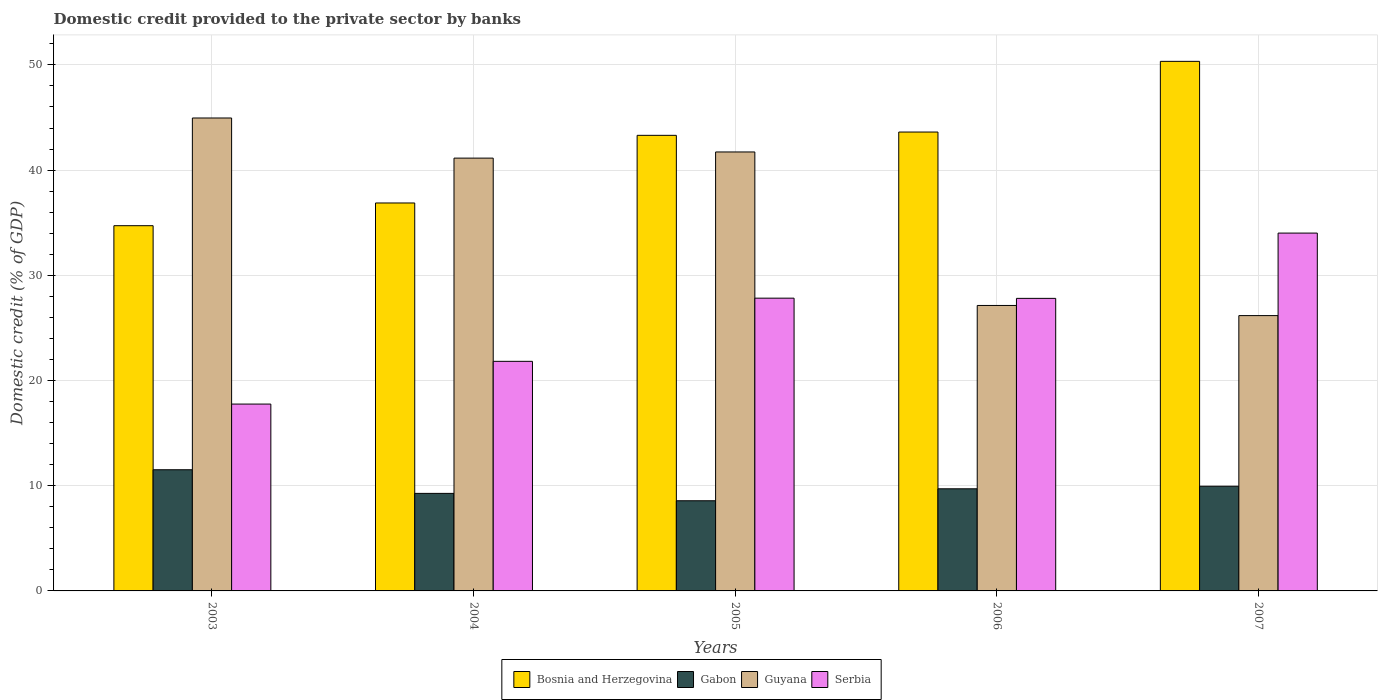How many bars are there on the 5th tick from the left?
Provide a succinct answer. 4. How many bars are there on the 2nd tick from the right?
Make the answer very short. 4. In how many cases, is the number of bars for a given year not equal to the number of legend labels?
Your response must be concise. 0. What is the domestic credit provided to the private sector by banks in Serbia in 2003?
Your response must be concise. 17.76. Across all years, what is the maximum domestic credit provided to the private sector by banks in Guyana?
Give a very brief answer. 44.96. Across all years, what is the minimum domestic credit provided to the private sector by banks in Guyana?
Your answer should be compact. 26.17. What is the total domestic credit provided to the private sector by banks in Serbia in the graph?
Ensure brevity in your answer.  129.24. What is the difference between the domestic credit provided to the private sector by banks in Guyana in 2004 and that in 2006?
Your response must be concise. 14. What is the difference between the domestic credit provided to the private sector by banks in Gabon in 2007 and the domestic credit provided to the private sector by banks in Bosnia and Herzegovina in 2003?
Your answer should be compact. -24.76. What is the average domestic credit provided to the private sector by banks in Gabon per year?
Offer a terse response. 9.8. In the year 2006, what is the difference between the domestic credit provided to the private sector by banks in Gabon and domestic credit provided to the private sector by banks in Guyana?
Your answer should be very brief. -17.43. In how many years, is the domestic credit provided to the private sector by banks in Bosnia and Herzegovina greater than 26 %?
Offer a terse response. 5. What is the ratio of the domestic credit provided to the private sector by banks in Guyana in 2004 to that in 2005?
Keep it short and to the point. 0.99. Is the domestic credit provided to the private sector by banks in Serbia in 2003 less than that in 2005?
Offer a terse response. Yes. Is the difference between the domestic credit provided to the private sector by banks in Gabon in 2003 and 2004 greater than the difference between the domestic credit provided to the private sector by banks in Guyana in 2003 and 2004?
Make the answer very short. No. What is the difference between the highest and the second highest domestic credit provided to the private sector by banks in Gabon?
Make the answer very short. 1.57. What is the difference between the highest and the lowest domestic credit provided to the private sector by banks in Guyana?
Your response must be concise. 18.78. In how many years, is the domestic credit provided to the private sector by banks in Serbia greater than the average domestic credit provided to the private sector by banks in Serbia taken over all years?
Your answer should be compact. 3. Is it the case that in every year, the sum of the domestic credit provided to the private sector by banks in Guyana and domestic credit provided to the private sector by banks in Gabon is greater than the sum of domestic credit provided to the private sector by banks in Serbia and domestic credit provided to the private sector by banks in Bosnia and Herzegovina?
Offer a terse response. No. What does the 4th bar from the left in 2006 represents?
Your answer should be compact. Serbia. What does the 1st bar from the right in 2004 represents?
Your answer should be very brief. Serbia. How many bars are there?
Offer a very short reply. 20. Are all the bars in the graph horizontal?
Give a very brief answer. No. How many years are there in the graph?
Your response must be concise. 5. Are the values on the major ticks of Y-axis written in scientific E-notation?
Your response must be concise. No. Does the graph contain any zero values?
Your answer should be very brief. No. Where does the legend appear in the graph?
Your response must be concise. Bottom center. How many legend labels are there?
Ensure brevity in your answer.  4. What is the title of the graph?
Make the answer very short. Domestic credit provided to the private sector by banks. What is the label or title of the Y-axis?
Your answer should be compact. Domestic credit (% of GDP). What is the Domestic credit (% of GDP) in Bosnia and Herzegovina in 2003?
Provide a short and direct response. 34.72. What is the Domestic credit (% of GDP) in Gabon in 2003?
Make the answer very short. 11.52. What is the Domestic credit (% of GDP) of Guyana in 2003?
Your answer should be compact. 44.96. What is the Domestic credit (% of GDP) of Serbia in 2003?
Provide a short and direct response. 17.76. What is the Domestic credit (% of GDP) in Bosnia and Herzegovina in 2004?
Offer a terse response. 36.88. What is the Domestic credit (% of GDP) in Gabon in 2004?
Offer a terse response. 9.27. What is the Domestic credit (% of GDP) of Guyana in 2004?
Keep it short and to the point. 41.14. What is the Domestic credit (% of GDP) of Serbia in 2004?
Make the answer very short. 21.82. What is the Domestic credit (% of GDP) of Bosnia and Herzegovina in 2005?
Provide a short and direct response. 43.31. What is the Domestic credit (% of GDP) of Gabon in 2005?
Ensure brevity in your answer.  8.57. What is the Domestic credit (% of GDP) of Guyana in 2005?
Your answer should be very brief. 41.73. What is the Domestic credit (% of GDP) of Serbia in 2005?
Provide a short and direct response. 27.83. What is the Domestic credit (% of GDP) in Bosnia and Herzegovina in 2006?
Your answer should be very brief. 43.62. What is the Domestic credit (% of GDP) in Gabon in 2006?
Make the answer very short. 9.71. What is the Domestic credit (% of GDP) in Guyana in 2006?
Your answer should be compact. 27.14. What is the Domestic credit (% of GDP) in Serbia in 2006?
Your answer should be very brief. 27.81. What is the Domestic credit (% of GDP) in Bosnia and Herzegovina in 2007?
Offer a very short reply. 50.34. What is the Domestic credit (% of GDP) in Gabon in 2007?
Give a very brief answer. 9.95. What is the Domestic credit (% of GDP) in Guyana in 2007?
Ensure brevity in your answer.  26.17. What is the Domestic credit (% of GDP) in Serbia in 2007?
Give a very brief answer. 34.01. Across all years, what is the maximum Domestic credit (% of GDP) in Bosnia and Herzegovina?
Your response must be concise. 50.34. Across all years, what is the maximum Domestic credit (% of GDP) in Gabon?
Provide a succinct answer. 11.52. Across all years, what is the maximum Domestic credit (% of GDP) of Guyana?
Give a very brief answer. 44.96. Across all years, what is the maximum Domestic credit (% of GDP) of Serbia?
Make the answer very short. 34.01. Across all years, what is the minimum Domestic credit (% of GDP) in Bosnia and Herzegovina?
Your answer should be compact. 34.72. Across all years, what is the minimum Domestic credit (% of GDP) in Gabon?
Offer a terse response. 8.57. Across all years, what is the minimum Domestic credit (% of GDP) in Guyana?
Your answer should be very brief. 26.17. Across all years, what is the minimum Domestic credit (% of GDP) of Serbia?
Ensure brevity in your answer.  17.76. What is the total Domestic credit (% of GDP) in Bosnia and Herzegovina in the graph?
Give a very brief answer. 208.86. What is the total Domestic credit (% of GDP) in Gabon in the graph?
Provide a succinct answer. 49.02. What is the total Domestic credit (% of GDP) in Guyana in the graph?
Keep it short and to the point. 181.13. What is the total Domestic credit (% of GDP) in Serbia in the graph?
Your answer should be compact. 129.24. What is the difference between the Domestic credit (% of GDP) of Bosnia and Herzegovina in 2003 and that in 2004?
Provide a short and direct response. -2.16. What is the difference between the Domestic credit (% of GDP) of Gabon in 2003 and that in 2004?
Ensure brevity in your answer.  2.25. What is the difference between the Domestic credit (% of GDP) in Guyana in 2003 and that in 2004?
Offer a terse response. 3.82. What is the difference between the Domestic credit (% of GDP) of Serbia in 2003 and that in 2004?
Give a very brief answer. -4.06. What is the difference between the Domestic credit (% of GDP) of Bosnia and Herzegovina in 2003 and that in 2005?
Your response must be concise. -8.59. What is the difference between the Domestic credit (% of GDP) of Gabon in 2003 and that in 2005?
Provide a short and direct response. 2.95. What is the difference between the Domestic credit (% of GDP) of Guyana in 2003 and that in 2005?
Your answer should be very brief. 3.23. What is the difference between the Domestic credit (% of GDP) in Serbia in 2003 and that in 2005?
Offer a very short reply. -10.07. What is the difference between the Domestic credit (% of GDP) of Bosnia and Herzegovina in 2003 and that in 2006?
Provide a short and direct response. -8.9. What is the difference between the Domestic credit (% of GDP) in Gabon in 2003 and that in 2006?
Provide a succinct answer. 1.81. What is the difference between the Domestic credit (% of GDP) of Guyana in 2003 and that in 2006?
Provide a short and direct response. 17.82. What is the difference between the Domestic credit (% of GDP) in Serbia in 2003 and that in 2006?
Your answer should be very brief. -10.05. What is the difference between the Domestic credit (% of GDP) of Bosnia and Herzegovina in 2003 and that in 2007?
Give a very brief answer. -15.62. What is the difference between the Domestic credit (% of GDP) of Gabon in 2003 and that in 2007?
Ensure brevity in your answer.  1.57. What is the difference between the Domestic credit (% of GDP) in Guyana in 2003 and that in 2007?
Provide a succinct answer. 18.78. What is the difference between the Domestic credit (% of GDP) in Serbia in 2003 and that in 2007?
Offer a terse response. -16.25. What is the difference between the Domestic credit (% of GDP) of Bosnia and Herzegovina in 2004 and that in 2005?
Give a very brief answer. -6.43. What is the difference between the Domestic credit (% of GDP) in Gabon in 2004 and that in 2005?
Provide a succinct answer. 0.7. What is the difference between the Domestic credit (% of GDP) in Guyana in 2004 and that in 2005?
Make the answer very short. -0.59. What is the difference between the Domestic credit (% of GDP) of Serbia in 2004 and that in 2005?
Your response must be concise. -6. What is the difference between the Domestic credit (% of GDP) of Bosnia and Herzegovina in 2004 and that in 2006?
Keep it short and to the point. -6.74. What is the difference between the Domestic credit (% of GDP) in Gabon in 2004 and that in 2006?
Offer a terse response. -0.44. What is the difference between the Domestic credit (% of GDP) in Guyana in 2004 and that in 2006?
Offer a very short reply. 14. What is the difference between the Domestic credit (% of GDP) of Serbia in 2004 and that in 2006?
Offer a very short reply. -5.98. What is the difference between the Domestic credit (% of GDP) in Bosnia and Herzegovina in 2004 and that in 2007?
Your answer should be very brief. -13.46. What is the difference between the Domestic credit (% of GDP) in Gabon in 2004 and that in 2007?
Offer a terse response. -0.68. What is the difference between the Domestic credit (% of GDP) of Guyana in 2004 and that in 2007?
Offer a very short reply. 14.97. What is the difference between the Domestic credit (% of GDP) of Serbia in 2004 and that in 2007?
Offer a very short reply. -12.19. What is the difference between the Domestic credit (% of GDP) in Bosnia and Herzegovina in 2005 and that in 2006?
Provide a succinct answer. -0.31. What is the difference between the Domestic credit (% of GDP) in Gabon in 2005 and that in 2006?
Your answer should be very brief. -1.14. What is the difference between the Domestic credit (% of GDP) of Guyana in 2005 and that in 2006?
Keep it short and to the point. 14.59. What is the difference between the Domestic credit (% of GDP) of Serbia in 2005 and that in 2006?
Offer a terse response. 0.02. What is the difference between the Domestic credit (% of GDP) of Bosnia and Herzegovina in 2005 and that in 2007?
Offer a very short reply. -7.03. What is the difference between the Domestic credit (% of GDP) of Gabon in 2005 and that in 2007?
Offer a very short reply. -1.38. What is the difference between the Domestic credit (% of GDP) of Guyana in 2005 and that in 2007?
Your answer should be very brief. 15.55. What is the difference between the Domestic credit (% of GDP) in Serbia in 2005 and that in 2007?
Give a very brief answer. -6.19. What is the difference between the Domestic credit (% of GDP) of Bosnia and Herzegovina in 2006 and that in 2007?
Your response must be concise. -6.72. What is the difference between the Domestic credit (% of GDP) in Gabon in 2006 and that in 2007?
Provide a succinct answer. -0.24. What is the difference between the Domestic credit (% of GDP) in Guyana in 2006 and that in 2007?
Provide a succinct answer. 0.96. What is the difference between the Domestic credit (% of GDP) of Serbia in 2006 and that in 2007?
Your response must be concise. -6.21. What is the difference between the Domestic credit (% of GDP) of Bosnia and Herzegovina in 2003 and the Domestic credit (% of GDP) of Gabon in 2004?
Provide a succinct answer. 25.45. What is the difference between the Domestic credit (% of GDP) in Bosnia and Herzegovina in 2003 and the Domestic credit (% of GDP) in Guyana in 2004?
Offer a terse response. -6.42. What is the difference between the Domestic credit (% of GDP) in Bosnia and Herzegovina in 2003 and the Domestic credit (% of GDP) in Serbia in 2004?
Your answer should be very brief. 12.89. What is the difference between the Domestic credit (% of GDP) in Gabon in 2003 and the Domestic credit (% of GDP) in Guyana in 2004?
Offer a terse response. -29.62. What is the difference between the Domestic credit (% of GDP) in Gabon in 2003 and the Domestic credit (% of GDP) in Serbia in 2004?
Your response must be concise. -10.31. What is the difference between the Domestic credit (% of GDP) of Guyana in 2003 and the Domestic credit (% of GDP) of Serbia in 2004?
Ensure brevity in your answer.  23.13. What is the difference between the Domestic credit (% of GDP) in Bosnia and Herzegovina in 2003 and the Domestic credit (% of GDP) in Gabon in 2005?
Keep it short and to the point. 26.15. What is the difference between the Domestic credit (% of GDP) of Bosnia and Herzegovina in 2003 and the Domestic credit (% of GDP) of Guyana in 2005?
Your response must be concise. -7.01. What is the difference between the Domestic credit (% of GDP) of Bosnia and Herzegovina in 2003 and the Domestic credit (% of GDP) of Serbia in 2005?
Offer a very short reply. 6.89. What is the difference between the Domestic credit (% of GDP) of Gabon in 2003 and the Domestic credit (% of GDP) of Guyana in 2005?
Ensure brevity in your answer.  -30.21. What is the difference between the Domestic credit (% of GDP) in Gabon in 2003 and the Domestic credit (% of GDP) in Serbia in 2005?
Provide a short and direct response. -16.31. What is the difference between the Domestic credit (% of GDP) in Guyana in 2003 and the Domestic credit (% of GDP) in Serbia in 2005?
Your response must be concise. 17.13. What is the difference between the Domestic credit (% of GDP) of Bosnia and Herzegovina in 2003 and the Domestic credit (% of GDP) of Gabon in 2006?
Ensure brevity in your answer.  25.01. What is the difference between the Domestic credit (% of GDP) of Bosnia and Herzegovina in 2003 and the Domestic credit (% of GDP) of Guyana in 2006?
Offer a very short reply. 7.58. What is the difference between the Domestic credit (% of GDP) of Bosnia and Herzegovina in 2003 and the Domestic credit (% of GDP) of Serbia in 2006?
Provide a short and direct response. 6.91. What is the difference between the Domestic credit (% of GDP) of Gabon in 2003 and the Domestic credit (% of GDP) of Guyana in 2006?
Your response must be concise. -15.62. What is the difference between the Domestic credit (% of GDP) of Gabon in 2003 and the Domestic credit (% of GDP) of Serbia in 2006?
Your response must be concise. -16.29. What is the difference between the Domestic credit (% of GDP) in Guyana in 2003 and the Domestic credit (% of GDP) in Serbia in 2006?
Your answer should be very brief. 17.15. What is the difference between the Domestic credit (% of GDP) in Bosnia and Herzegovina in 2003 and the Domestic credit (% of GDP) in Gabon in 2007?
Your answer should be very brief. 24.76. What is the difference between the Domestic credit (% of GDP) in Bosnia and Herzegovina in 2003 and the Domestic credit (% of GDP) in Guyana in 2007?
Keep it short and to the point. 8.55. What is the difference between the Domestic credit (% of GDP) in Bosnia and Herzegovina in 2003 and the Domestic credit (% of GDP) in Serbia in 2007?
Ensure brevity in your answer.  0.7. What is the difference between the Domestic credit (% of GDP) of Gabon in 2003 and the Domestic credit (% of GDP) of Guyana in 2007?
Provide a succinct answer. -14.65. What is the difference between the Domestic credit (% of GDP) in Gabon in 2003 and the Domestic credit (% of GDP) in Serbia in 2007?
Your answer should be very brief. -22.5. What is the difference between the Domestic credit (% of GDP) in Guyana in 2003 and the Domestic credit (% of GDP) in Serbia in 2007?
Give a very brief answer. 10.94. What is the difference between the Domestic credit (% of GDP) in Bosnia and Herzegovina in 2004 and the Domestic credit (% of GDP) in Gabon in 2005?
Offer a very short reply. 28.31. What is the difference between the Domestic credit (% of GDP) of Bosnia and Herzegovina in 2004 and the Domestic credit (% of GDP) of Guyana in 2005?
Give a very brief answer. -4.85. What is the difference between the Domestic credit (% of GDP) in Bosnia and Herzegovina in 2004 and the Domestic credit (% of GDP) in Serbia in 2005?
Ensure brevity in your answer.  9.05. What is the difference between the Domestic credit (% of GDP) of Gabon in 2004 and the Domestic credit (% of GDP) of Guyana in 2005?
Make the answer very short. -32.45. What is the difference between the Domestic credit (% of GDP) of Gabon in 2004 and the Domestic credit (% of GDP) of Serbia in 2005?
Give a very brief answer. -18.56. What is the difference between the Domestic credit (% of GDP) of Guyana in 2004 and the Domestic credit (% of GDP) of Serbia in 2005?
Offer a terse response. 13.31. What is the difference between the Domestic credit (% of GDP) of Bosnia and Herzegovina in 2004 and the Domestic credit (% of GDP) of Gabon in 2006?
Ensure brevity in your answer.  27.17. What is the difference between the Domestic credit (% of GDP) in Bosnia and Herzegovina in 2004 and the Domestic credit (% of GDP) in Guyana in 2006?
Your answer should be compact. 9.74. What is the difference between the Domestic credit (% of GDP) in Bosnia and Herzegovina in 2004 and the Domestic credit (% of GDP) in Serbia in 2006?
Ensure brevity in your answer.  9.07. What is the difference between the Domestic credit (% of GDP) in Gabon in 2004 and the Domestic credit (% of GDP) in Guyana in 2006?
Provide a short and direct response. -17.86. What is the difference between the Domestic credit (% of GDP) in Gabon in 2004 and the Domestic credit (% of GDP) in Serbia in 2006?
Offer a very short reply. -18.54. What is the difference between the Domestic credit (% of GDP) of Guyana in 2004 and the Domestic credit (% of GDP) of Serbia in 2006?
Ensure brevity in your answer.  13.33. What is the difference between the Domestic credit (% of GDP) of Bosnia and Herzegovina in 2004 and the Domestic credit (% of GDP) of Gabon in 2007?
Your answer should be compact. 26.92. What is the difference between the Domestic credit (% of GDP) of Bosnia and Herzegovina in 2004 and the Domestic credit (% of GDP) of Guyana in 2007?
Provide a succinct answer. 10.71. What is the difference between the Domestic credit (% of GDP) of Bosnia and Herzegovina in 2004 and the Domestic credit (% of GDP) of Serbia in 2007?
Your response must be concise. 2.86. What is the difference between the Domestic credit (% of GDP) in Gabon in 2004 and the Domestic credit (% of GDP) in Guyana in 2007?
Provide a succinct answer. -16.9. What is the difference between the Domestic credit (% of GDP) of Gabon in 2004 and the Domestic credit (% of GDP) of Serbia in 2007?
Make the answer very short. -24.74. What is the difference between the Domestic credit (% of GDP) in Guyana in 2004 and the Domestic credit (% of GDP) in Serbia in 2007?
Keep it short and to the point. 7.13. What is the difference between the Domestic credit (% of GDP) in Bosnia and Herzegovina in 2005 and the Domestic credit (% of GDP) in Gabon in 2006?
Your answer should be very brief. 33.6. What is the difference between the Domestic credit (% of GDP) of Bosnia and Herzegovina in 2005 and the Domestic credit (% of GDP) of Guyana in 2006?
Your answer should be compact. 16.17. What is the difference between the Domestic credit (% of GDP) in Bosnia and Herzegovina in 2005 and the Domestic credit (% of GDP) in Serbia in 2006?
Your answer should be very brief. 15.5. What is the difference between the Domestic credit (% of GDP) of Gabon in 2005 and the Domestic credit (% of GDP) of Guyana in 2006?
Make the answer very short. -18.56. What is the difference between the Domestic credit (% of GDP) of Gabon in 2005 and the Domestic credit (% of GDP) of Serbia in 2006?
Provide a succinct answer. -19.24. What is the difference between the Domestic credit (% of GDP) of Guyana in 2005 and the Domestic credit (% of GDP) of Serbia in 2006?
Your answer should be very brief. 13.92. What is the difference between the Domestic credit (% of GDP) of Bosnia and Herzegovina in 2005 and the Domestic credit (% of GDP) of Gabon in 2007?
Your response must be concise. 33.35. What is the difference between the Domestic credit (% of GDP) in Bosnia and Herzegovina in 2005 and the Domestic credit (% of GDP) in Guyana in 2007?
Offer a terse response. 17.13. What is the difference between the Domestic credit (% of GDP) in Bosnia and Herzegovina in 2005 and the Domestic credit (% of GDP) in Serbia in 2007?
Your response must be concise. 9.29. What is the difference between the Domestic credit (% of GDP) in Gabon in 2005 and the Domestic credit (% of GDP) in Guyana in 2007?
Offer a very short reply. -17.6. What is the difference between the Domestic credit (% of GDP) in Gabon in 2005 and the Domestic credit (% of GDP) in Serbia in 2007?
Your response must be concise. -25.44. What is the difference between the Domestic credit (% of GDP) in Guyana in 2005 and the Domestic credit (% of GDP) in Serbia in 2007?
Offer a terse response. 7.71. What is the difference between the Domestic credit (% of GDP) in Bosnia and Herzegovina in 2006 and the Domestic credit (% of GDP) in Gabon in 2007?
Your answer should be compact. 33.67. What is the difference between the Domestic credit (% of GDP) in Bosnia and Herzegovina in 2006 and the Domestic credit (% of GDP) in Guyana in 2007?
Offer a very short reply. 17.45. What is the difference between the Domestic credit (% of GDP) of Bosnia and Herzegovina in 2006 and the Domestic credit (% of GDP) of Serbia in 2007?
Ensure brevity in your answer.  9.6. What is the difference between the Domestic credit (% of GDP) of Gabon in 2006 and the Domestic credit (% of GDP) of Guyana in 2007?
Provide a short and direct response. -16.46. What is the difference between the Domestic credit (% of GDP) in Gabon in 2006 and the Domestic credit (% of GDP) in Serbia in 2007?
Provide a short and direct response. -24.31. What is the difference between the Domestic credit (% of GDP) of Guyana in 2006 and the Domestic credit (% of GDP) of Serbia in 2007?
Provide a succinct answer. -6.88. What is the average Domestic credit (% of GDP) in Bosnia and Herzegovina per year?
Your answer should be compact. 41.77. What is the average Domestic credit (% of GDP) in Gabon per year?
Keep it short and to the point. 9.8. What is the average Domestic credit (% of GDP) in Guyana per year?
Provide a short and direct response. 36.23. What is the average Domestic credit (% of GDP) of Serbia per year?
Your answer should be compact. 25.85. In the year 2003, what is the difference between the Domestic credit (% of GDP) in Bosnia and Herzegovina and Domestic credit (% of GDP) in Gabon?
Your answer should be very brief. 23.2. In the year 2003, what is the difference between the Domestic credit (% of GDP) of Bosnia and Herzegovina and Domestic credit (% of GDP) of Guyana?
Make the answer very short. -10.24. In the year 2003, what is the difference between the Domestic credit (% of GDP) of Bosnia and Herzegovina and Domestic credit (% of GDP) of Serbia?
Your answer should be compact. 16.96. In the year 2003, what is the difference between the Domestic credit (% of GDP) of Gabon and Domestic credit (% of GDP) of Guyana?
Provide a succinct answer. -33.44. In the year 2003, what is the difference between the Domestic credit (% of GDP) of Gabon and Domestic credit (% of GDP) of Serbia?
Your answer should be very brief. -6.24. In the year 2003, what is the difference between the Domestic credit (% of GDP) of Guyana and Domestic credit (% of GDP) of Serbia?
Keep it short and to the point. 27.19. In the year 2004, what is the difference between the Domestic credit (% of GDP) in Bosnia and Herzegovina and Domestic credit (% of GDP) in Gabon?
Offer a very short reply. 27.61. In the year 2004, what is the difference between the Domestic credit (% of GDP) in Bosnia and Herzegovina and Domestic credit (% of GDP) in Guyana?
Keep it short and to the point. -4.26. In the year 2004, what is the difference between the Domestic credit (% of GDP) of Bosnia and Herzegovina and Domestic credit (% of GDP) of Serbia?
Ensure brevity in your answer.  15.05. In the year 2004, what is the difference between the Domestic credit (% of GDP) in Gabon and Domestic credit (% of GDP) in Guyana?
Provide a short and direct response. -31.87. In the year 2004, what is the difference between the Domestic credit (% of GDP) of Gabon and Domestic credit (% of GDP) of Serbia?
Provide a short and direct response. -12.55. In the year 2004, what is the difference between the Domestic credit (% of GDP) in Guyana and Domestic credit (% of GDP) in Serbia?
Your response must be concise. 19.32. In the year 2005, what is the difference between the Domestic credit (% of GDP) of Bosnia and Herzegovina and Domestic credit (% of GDP) of Gabon?
Your response must be concise. 34.73. In the year 2005, what is the difference between the Domestic credit (% of GDP) in Bosnia and Herzegovina and Domestic credit (% of GDP) in Guyana?
Your answer should be very brief. 1.58. In the year 2005, what is the difference between the Domestic credit (% of GDP) in Bosnia and Herzegovina and Domestic credit (% of GDP) in Serbia?
Provide a short and direct response. 15.48. In the year 2005, what is the difference between the Domestic credit (% of GDP) of Gabon and Domestic credit (% of GDP) of Guyana?
Your answer should be very brief. -33.15. In the year 2005, what is the difference between the Domestic credit (% of GDP) of Gabon and Domestic credit (% of GDP) of Serbia?
Keep it short and to the point. -19.26. In the year 2005, what is the difference between the Domestic credit (% of GDP) in Guyana and Domestic credit (% of GDP) in Serbia?
Your response must be concise. 13.9. In the year 2006, what is the difference between the Domestic credit (% of GDP) of Bosnia and Herzegovina and Domestic credit (% of GDP) of Gabon?
Offer a terse response. 33.91. In the year 2006, what is the difference between the Domestic credit (% of GDP) in Bosnia and Herzegovina and Domestic credit (% of GDP) in Guyana?
Provide a succinct answer. 16.48. In the year 2006, what is the difference between the Domestic credit (% of GDP) in Bosnia and Herzegovina and Domestic credit (% of GDP) in Serbia?
Offer a terse response. 15.81. In the year 2006, what is the difference between the Domestic credit (% of GDP) of Gabon and Domestic credit (% of GDP) of Guyana?
Keep it short and to the point. -17.43. In the year 2006, what is the difference between the Domestic credit (% of GDP) in Gabon and Domestic credit (% of GDP) in Serbia?
Your answer should be compact. -18.1. In the year 2006, what is the difference between the Domestic credit (% of GDP) in Guyana and Domestic credit (% of GDP) in Serbia?
Give a very brief answer. -0.67. In the year 2007, what is the difference between the Domestic credit (% of GDP) of Bosnia and Herzegovina and Domestic credit (% of GDP) of Gabon?
Ensure brevity in your answer.  40.39. In the year 2007, what is the difference between the Domestic credit (% of GDP) of Bosnia and Herzegovina and Domestic credit (% of GDP) of Guyana?
Offer a very short reply. 24.17. In the year 2007, what is the difference between the Domestic credit (% of GDP) in Bosnia and Herzegovina and Domestic credit (% of GDP) in Serbia?
Ensure brevity in your answer.  16.32. In the year 2007, what is the difference between the Domestic credit (% of GDP) of Gabon and Domestic credit (% of GDP) of Guyana?
Give a very brief answer. -16.22. In the year 2007, what is the difference between the Domestic credit (% of GDP) of Gabon and Domestic credit (% of GDP) of Serbia?
Your answer should be compact. -24.06. In the year 2007, what is the difference between the Domestic credit (% of GDP) of Guyana and Domestic credit (% of GDP) of Serbia?
Your answer should be very brief. -7.84. What is the ratio of the Domestic credit (% of GDP) of Bosnia and Herzegovina in 2003 to that in 2004?
Keep it short and to the point. 0.94. What is the ratio of the Domestic credit (% of GDP) in Gabon in 2003 to that in 2004?
Offer a terse response. 1.24. What is the ratio of the Domestic credit (% of GDP) in Guyana in 2003 to that in 2004?
Make the answer very short. 1.09. What is the ratio of the Domestic credit (% of GDP) of Serbia in 2003 to that in 2004?
Your response must be concise. 0.81. What is the ratio of the Domestic credit (% of GDP) of Bosnia and Herzegovina in 2003 to that in 2005?
Give a very brief answer. 0.8. What is the ratio of the Domestic credit (% of GDP) of Gabon in 2003 to that in 2005?
Your answer should be very brief. 1.34. What is the ratio of the Domestic credit (% of GDP) in Guyana in 2003 to that in 2005?
Provide a succinct answer. 1.08. What is the ratio of the Domestic credit (% of GDP) in Serbia in 2003 to that in 2005?
Your answer should be compact. 0.64. What is the ratio of the Domestic credit (% of GDP) of Bosnia and Herzegovina in 2003 to that in 2006?
Provide a succinct answer. 0.8. What is the ratio of the Domestic credit (% of GDP) in Gabon in 2003 to that in 2006?
Your answer should be very brief. 1.19. What is the ratio of the Domestic credit (% of GDP) of Guyana in 2003 to that in 2006?
Keep it short and to the point. 1.66. What is the ratio of the Domestic credit (% of GDP) in Serbia in 2003 to that in 2006?
Give a very brief answer. 0.64. What is the ratio of the Domestic credit (% of GDP) in Bosnia and Herzegovina in 2003 to that in 2007?
Your answer should be very brief. 0.69. What is the ratio of the Domestic credit (% of GDP) in Gabon in 2003 to that in 2007?
Ensure brevity in your answer.  1.16. What is the ratio of the Domestic credit (% of GDP) of Guyana in 2003 to that in 2007?
Your answer should be very brief. 1.72. What is the ratio of the Domestic credit (% of GDP) in Serbia in 2003 to that in 2007?
Give a very brief answer. 0.52. What is the ratio of the Domestic credit (% of GDP) of Bosnia and Herzegovina in 2004 to that in 2005?
Provide a short and direct response. 0.85. What is the ratio of the Domestic credit (% of GDP) in Gabon in 2004 to that in 2005?
Offer a very short reply. 1.08. What is the ratio of the Domestic credit (% of GDP) of Guyana in 2004 to that in 2005?
Your answer should be compact. 0.99. What is the ratio of the Domestic credit (% of GDP) of Serbia in 2004 to that in 2005?
Keep it short and to the point. 0.78. What is the ratio of the Domestic credit (% of GDP) in Bosnia and Herzegovina in 2004 to that in 2006?
Offer a very short reply. 0.85. What is the ratio of the Domestic credit (% of GDP) in Gabon in 2004 to that in 2006?
Provide a short and direct response. 0.95. What is the ratio of the Domestic credit (% of GDP) in Guyana in 2004 to that in 2006?
Make the answer very short. 1.52. What is the ratio of the Domestic credit (% of GDP) in Serbia in 2004 to that in 2006?
Make the answer very short. 0.78. What is the ratio of the Domestic credit (% of GDP) in Bosnia and Herzegovina in 2004 to that in 2007?
Give a very brief answer. 0.73. What is the ratio of the Domestic credit (% of GDP) of Gabon in 2004 to that in 2007?
Give a very brief answer. 0.93. What is the ratio of the Domestic credit (% of GDP) of Guyana in 2004 to that in 2007?
Offer a terse response. 1.57. What is the ratio of the Domestic credit (% of GDP) in Serbia in 2004 to that in 2007?
Keep it short and to the point. 0.64. What is the ratio of the Domestic credit (% of GDP) in Gabon in 2005 to that in 2006?
Give a very brief answer. 0.88. What is the ratio of the Domestic credit (% of GDP) in Guyana in 2005 to that in 2006?
Ensure brevity in your answer.  1.54. What is the ratio of the Domestic credit (% of GDP) of Bosnia and Herzegovina in 2005 to that in 2007?
Your answer should be compact. 0.86. What is the ratio of the Domestic credit (% of GDP) in Gabon in 2005 to that in 2007?
Offer a terse response. 0.86. What is the ratio of the Domestic credit (% of GDP) in Guyana in 2005 to that in 2007?
Provide a short and direct response. 1.59. What is the ratio of the Domestic credit (% of GDP) of Serbia in 2005 to that in 2007?
Provide a short and direct response. 0.82. What is the ratio of the Domestic credit (% of GDP) of Bosnia and Herzegovina in 2006 to that in 2007?
Ensure brevity in your answer.  0.87. What is the ratio of the Domestic credit (% of GDP) in Gabon in 2006 to that in 2007?
Your answer should be very brief. 0.98. What is the ratio of the Domestic credit (% of GDP) in Guyana in 2006 to that in 2007?
Offer a very short reply. 1.04. What is the ratio of the Domestic credit (% of GDP) in Serbia in 2006 to that in 2007?
Provide a succinct answer. 0.82. What is the difference between the highest and the second highest Domestic credit (% of GDP) of Bosnia and Herzegovina?
Make the answer very short. 6.72. What is the difference between the highest and the second highest Domestic credit (% of GDP) of Gabon?
Ensure brevity in your answer.  1.57. What is the difference between the highest and the second highest Domestic credit (% of GDP) of Guyana?
Keep it short and to the point. 3.23. What is the difference between the highest and the second highest Domestic credit (% of GDP) of Serbia?
Offer a terse response. 6.19. What is the difference between the highest and the lowest Domestic credit (% of GDP) in Bosnia and Herzegovina?
Your response must be concise. 15.62. What is the difference between the highest and the lowest Domestic credit (% of GDP) of Gabon?
Offer a very short reply. 2.95. What is the difference between the highest and the lowest Domestic credit (% of GDP) of Guyana?
Make the answer very short. 18.78. What is the difference between the highest and the lowest Domestic credit (% of GDP) of Serbia?
Your response must be concise. 16.25. 